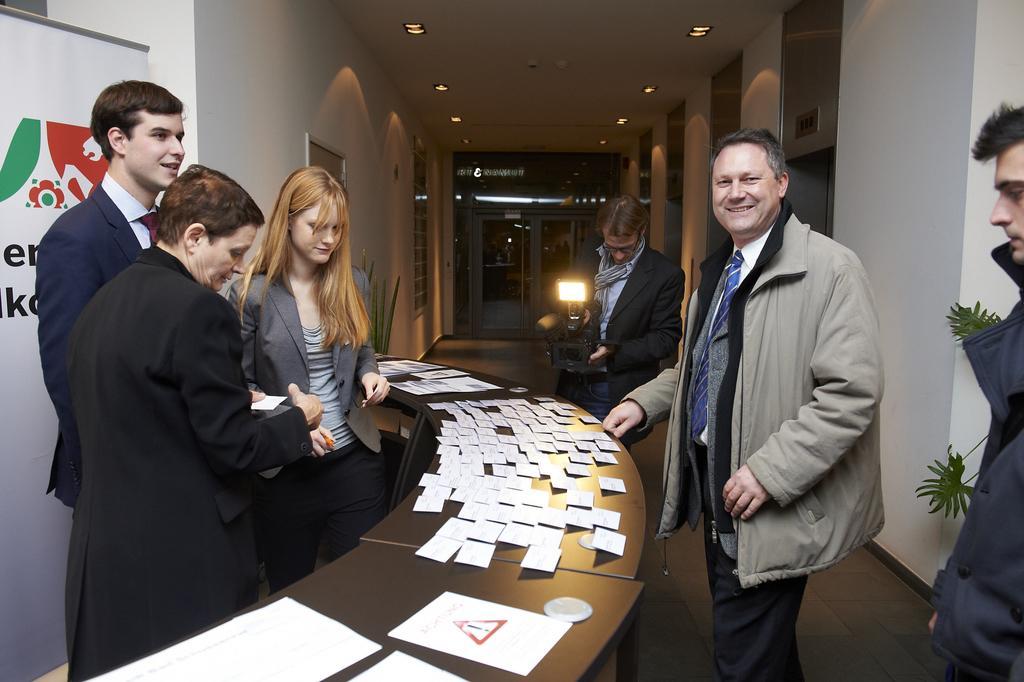How would you summarize this image in a sentence or two? In this image in front there are people. In front of them there is a table and on top of it there are papers. Behind them there is another person holding the camera. On both right and left side of the image there are plants. At the bottom of the image there is a floor. On the left side of the image there is a banner. In the background of the image there is a door. There is a wall. On top of the image there are lights. 